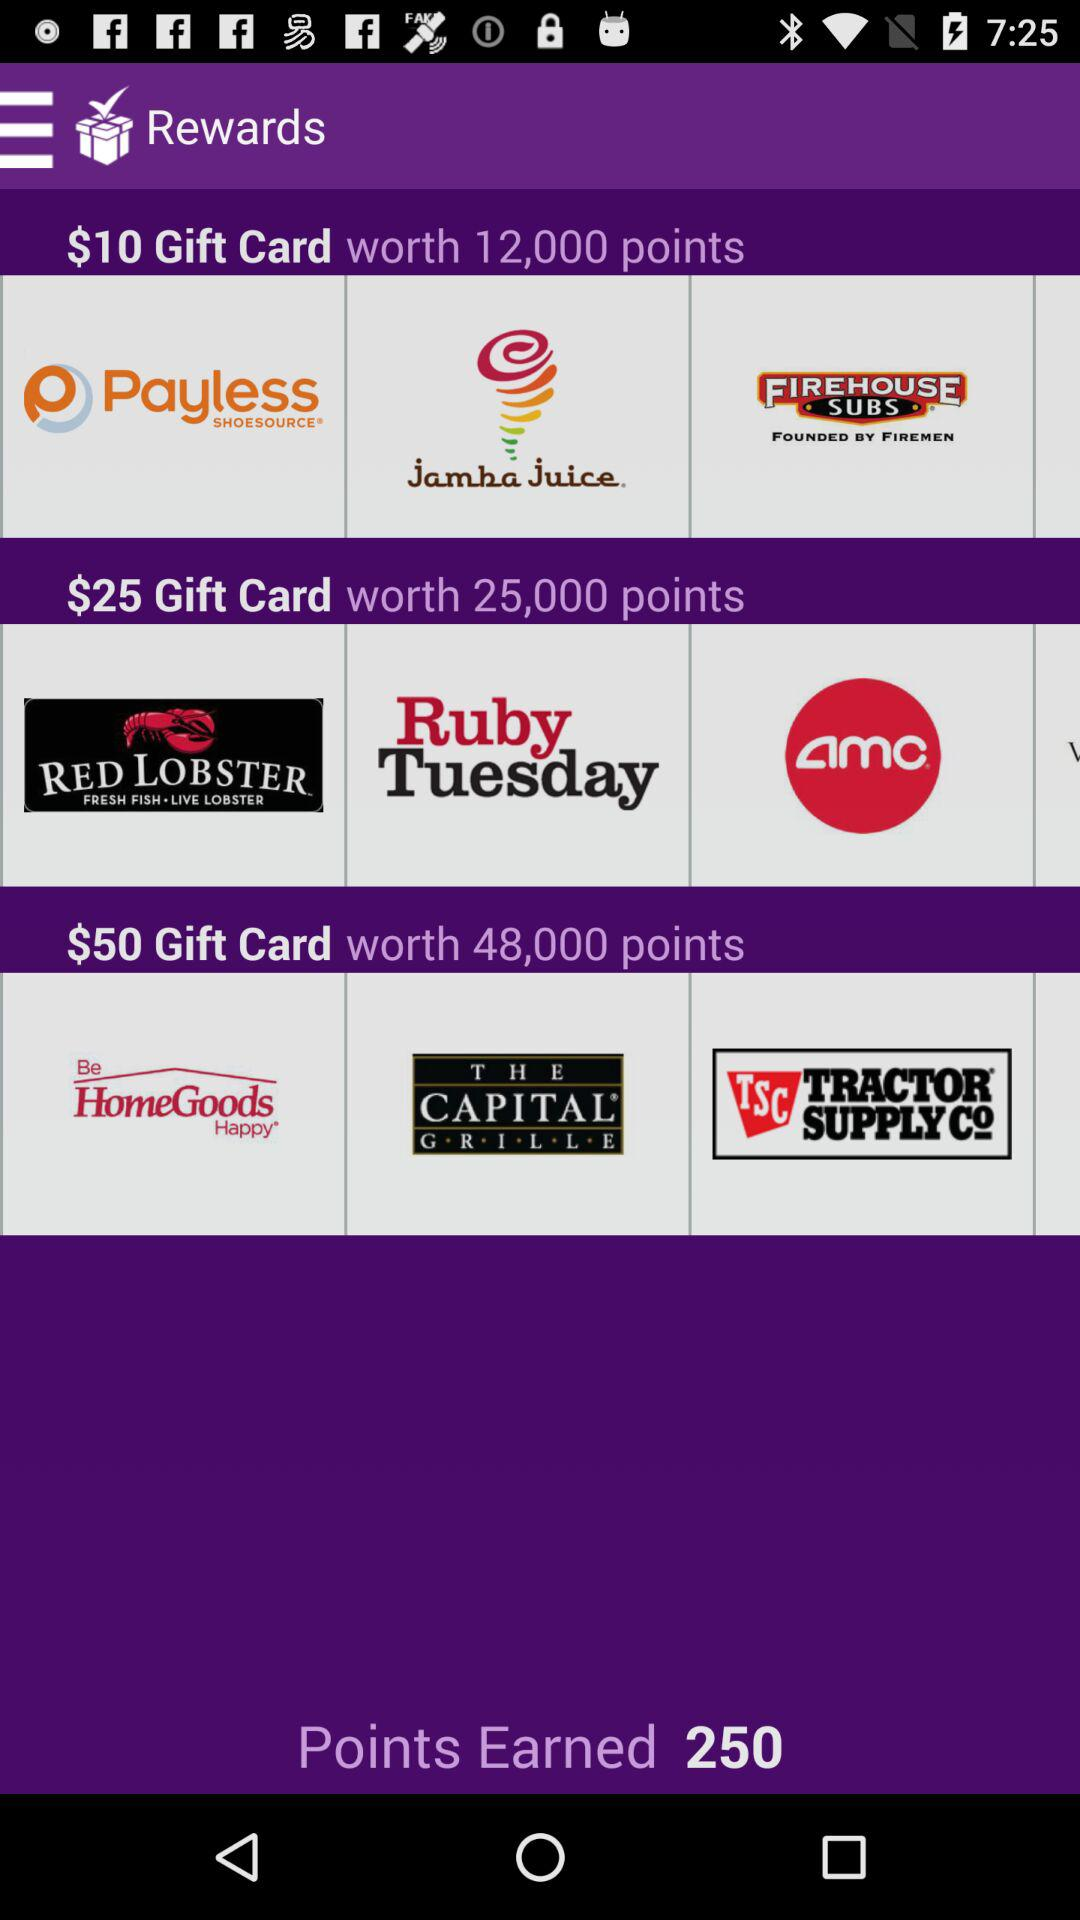How many more points are required for the $50 gift card than the $25 gift card?
Answer the question using a single word or phrase. 23000 